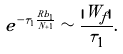Convert formula to latex. <formula><loc_0><loc_0><loc_500><loc_500>e ^ { - \tau _ { 1 } \frac { R b _ { 1 } } { N + 1 } } \sim \frac { | W _ { f } | } { \tau _ { 1 } } .</formula> 